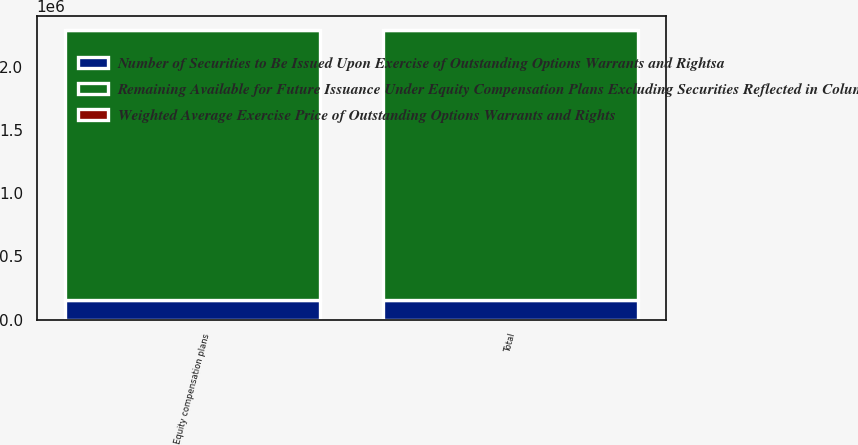Convert chart to OTSL. <chart><loc_0><loc_0><loc_500><loc_500><stacked_bar_chart><ecel><fcel>Equity compensation plans<fcel>Total<nl><fcel>Number of Securities to Be Issued Upon Exercise of Outstanding Options Warrants and Rightsa<fcel>151945<fcel>151945<nl><fcel>Weighted Average Exercise Price of Outstanding Options Warrants and Rights<fcel>24.61<fcel>24.61<nl><fcel>Remaining Available for Future Issuance Under Equity Compensation Plans Excluding Securities Reflected in Column A<fcel>2.14095e+06<fcel>2.14095e+06<nl></chart> 